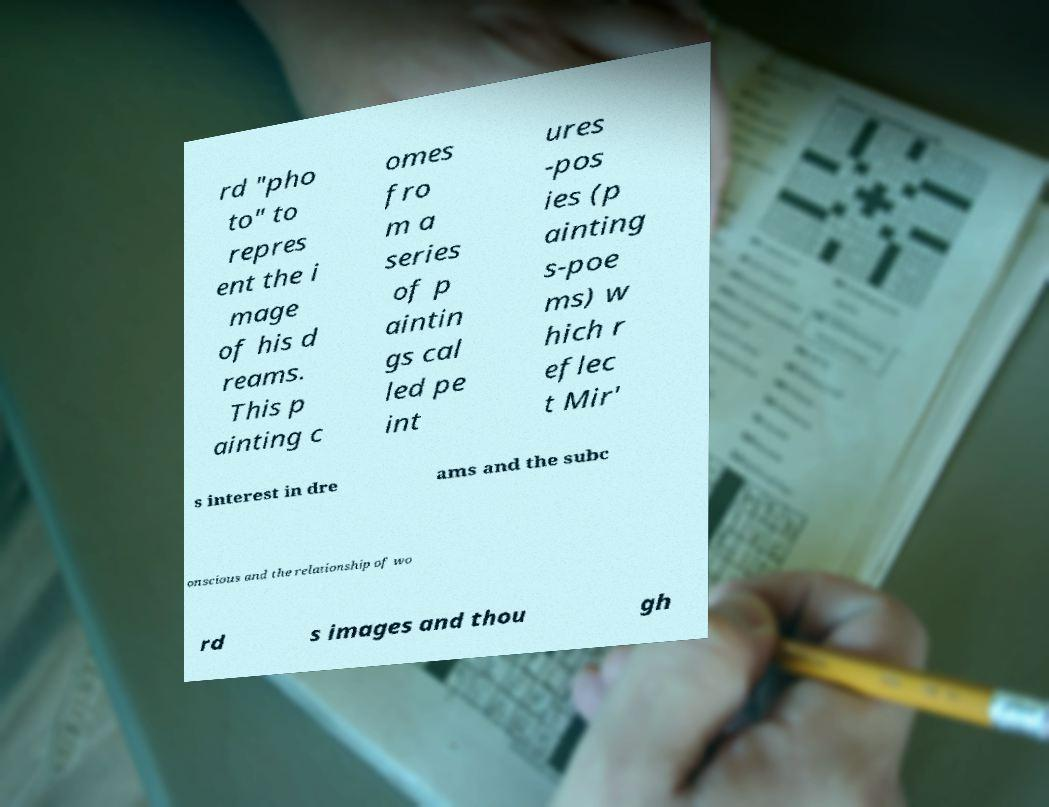What messages or text are displayed in this image? I need them in a readable, typed format. rd "pho to" to repres ent the i mage of his d reams. This p ainting c omes fro m a series of p aintin gs cal led pe int ures -pos ies (p ainting s-poe ms) w hich r eflec t Mir' s interest in dre ams and the subc onscious and the relationship of wo rd s images and thou gh 